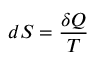<formula> <loc_0><loc_0><loc_500><loc_500>d S = { \frac { \delta Q } { T } }</formula> 